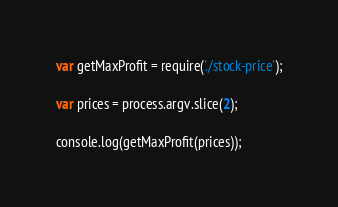<code> <loc_0><loc_0><loc_500><loc_500><_JavaScript_>var getMaxProfit = require('./stock-price');

var prices = process.argv.slice(2);

console.log(getMaxProfit(prices));
</code> 